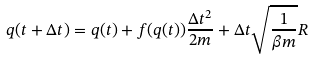Convert formula to latex. <formula><loc_0><loc_0><loc_500><loc_500>q ( t + \Delta t ) = q ( t ) + f ( q ( t ) ) \frac { \Delta t ^ { 2 } } { 2 m } + \Delta t \sqrt { \frac { 1 } { \beta m } } R</formula> 